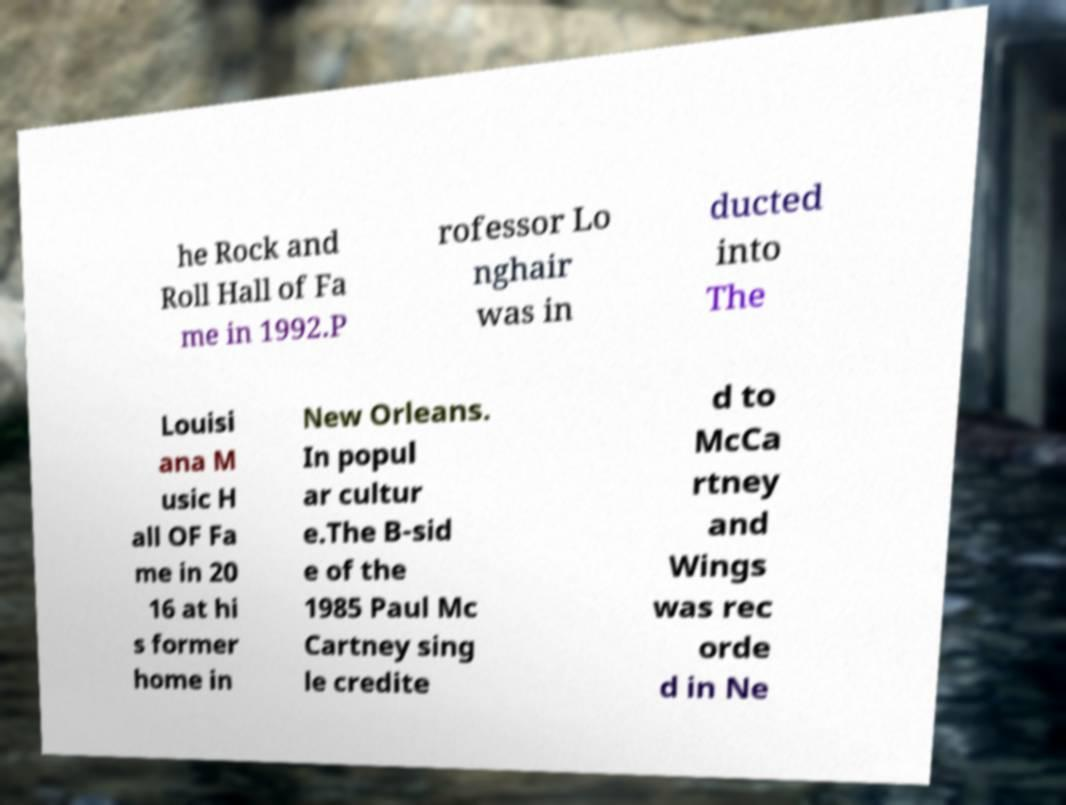Can you accurately transcribe the text from the provided image for me? he Rock and Roll Hall of Fa me in 1992.P rofessor Lo nghair was in ducted into The Louisi ana M usic H all OF Fa me in 20 16 at hi s former home in New Orleans. In popul ar cultur e.The B-sid e of the 1985 Paul Mc Cartney sing le credite d to McCa rtney and Wings was rec orde d in Ne 